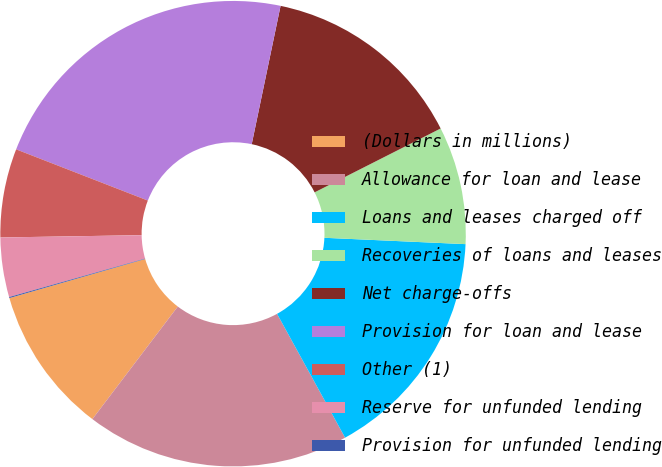Convert chart to OTSL. <chart><loc_0><loc_0><loc_500><loc_500><pie_chart><fcel>(Dollars in millions)<fcel>Allowance for loan and lease<fcel>Loans and leases charged off<fcel>Recoveries of loans and leases<fcel>Net charge-offs<fcel>Provision for loan and lease<fcel>Other (1)<fcel>Reserve for unfunded lending<fcel>Provision for unfunded lending<nl><fcel>10.21%<fcel>18.32%<fcel>16.29%<fcel>8.18%<fcel>14.26%<fcel>22.37%<fcel>6.16%<fcel>4.13%<fcel>0.07%<nl></chart> 